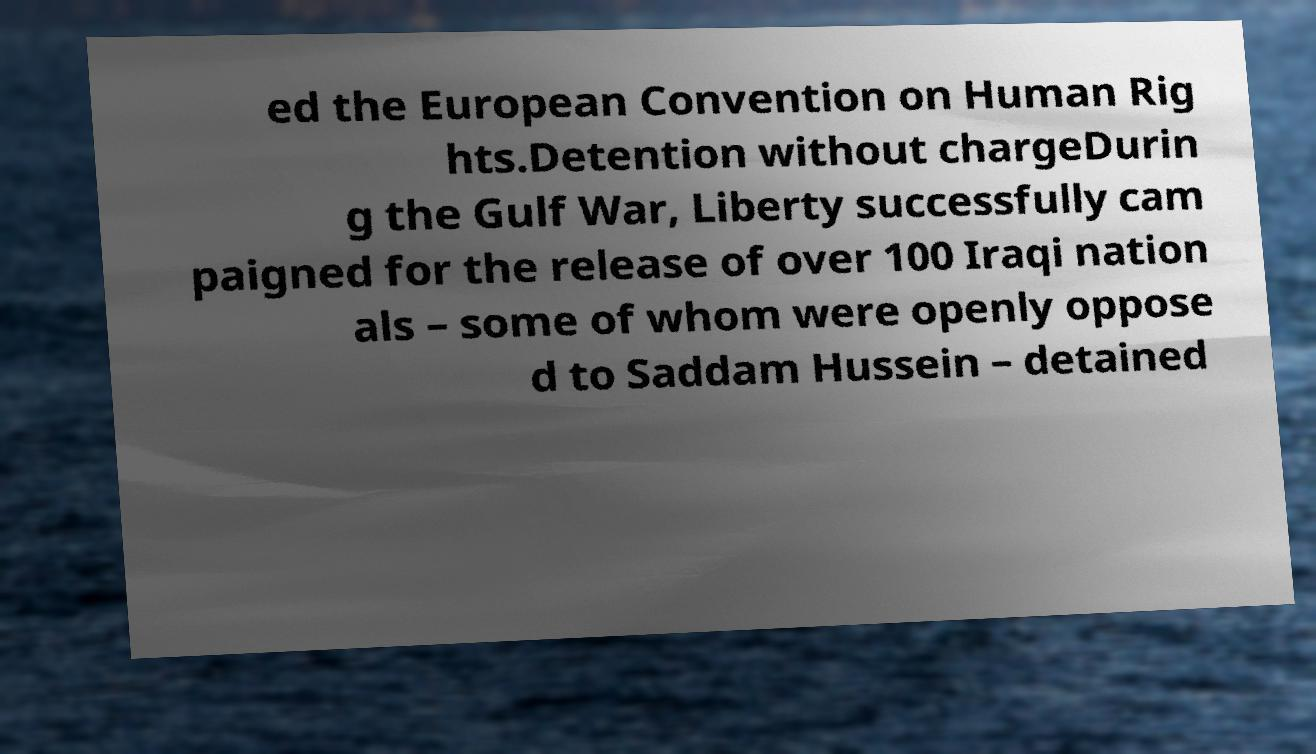Could you assist in decoding the text presented in this image and type it out clearly? ed the European Convention on Human Rig hts.Detention without chargeDurin g the Gulf War, Liberty successfully cam paigned for the release of over 100 Iraqi nation als – some of whom were openly oppose d to Saddam Hussein – detained 